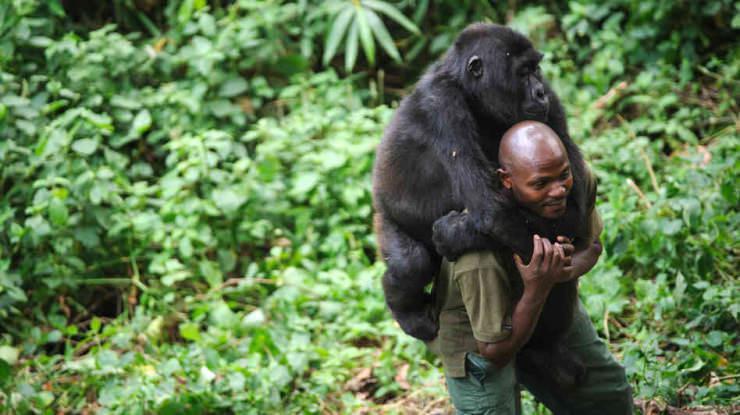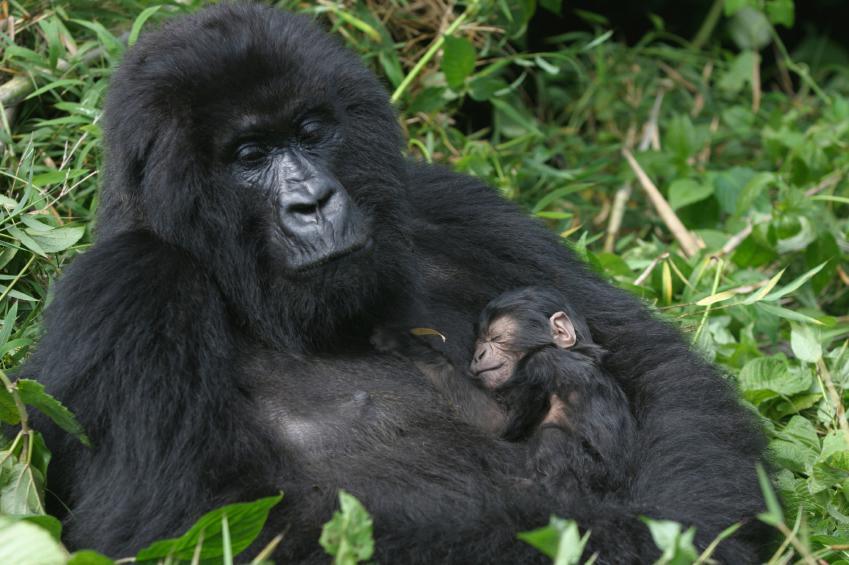The first image is the image on the left, the second image is the image on the right. Analyze the images presented: Is the assertion "One image shows a man in an olive-green shirt interacting with a gorilla." valid? Answer yes or no. Yes. The first image is the image on the left, the second image is the image on the right. Analyze the images presented: Is the assertion "There is a person in the image on the right." valid? Answer yes or no. No. 